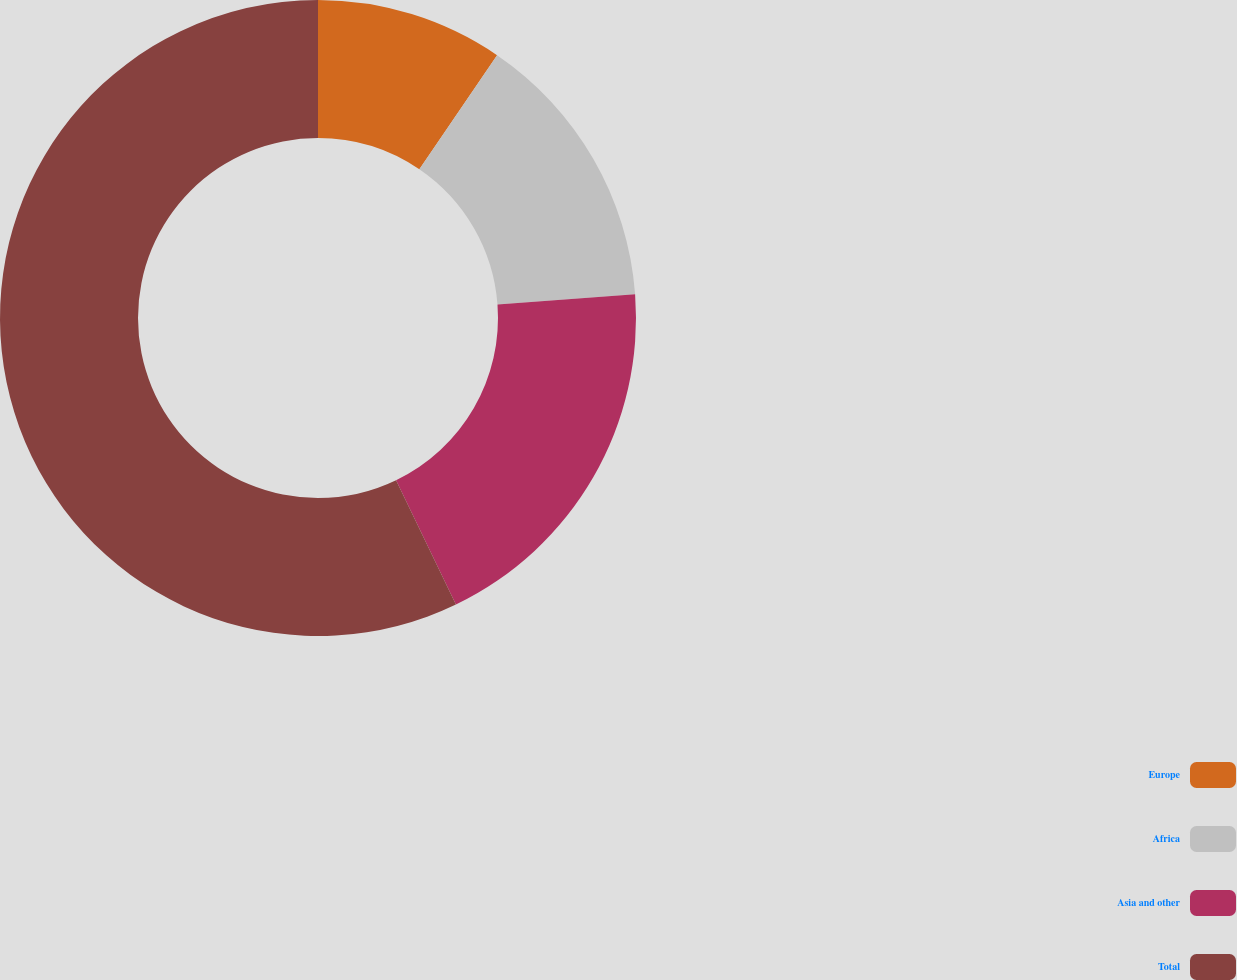<chart> <loc_0><loc_0><loc_500><loc_500><pie_chart><fcel>Europe<fcel>Africa<fcel>Asia and other<fcel>Total<nl><fcel>9.52%<fcel>14.29%<fcel>19.05%<fcel>57.14%<nl></chart> 